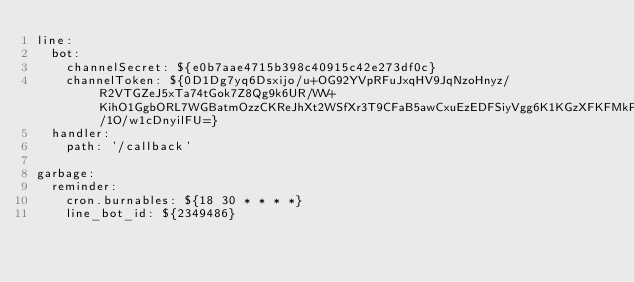Convert code to text. <code><loc_0><loc_0><loc_500><loc_500><_YAML_>line:
  bot:
    channelSecret: ${e0b7aae4715b398c40915c42e273df0c}
    channelToken: ${0D1Dg7yq6Dsxijo/u+OG92YVpRFuJxqHV9JqNzoHnyz/R2VTGZeJ5xTa74tGok7Z8Qg9k6UR/WV+KihO1GgbORL7WGBatmOzzCKReJhXt2WSfXr3T9CFaB5awCxuEzEDFSiyVgg6K1KGzXFKFMkPgwdB04t89/1O/w1cDnyilFU=}
  handler:
    path: '/callback'

garbage:
  reminder:
    cron.burnables: ${18 30 * * * *}
    line_bot_id: ${2349486}
</code> 